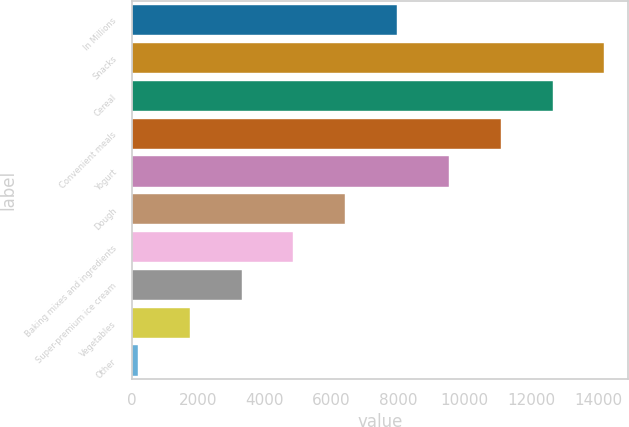<chart> <loc_0><loc_0><loc_500><loc_500><bar_chart><fcel>In Millions<fcel>Snacks<fcel>Cereal<fcel>Convenient meals<fcel>Yogurt<fcel>Dough<fcel>Baking mixes and ingredients<fcel>Super-premium ice cream<fcel>Vegetables<fcel>Other<nl><fcel>7967.4<fcel>14185.8<fcel>12631.2<fcel>11076.6<fcel>9522<fcel>6412.8<fcel>4858.2<fcel>3303.6<fcel>1749<fcel>194.4<nl></chart> 